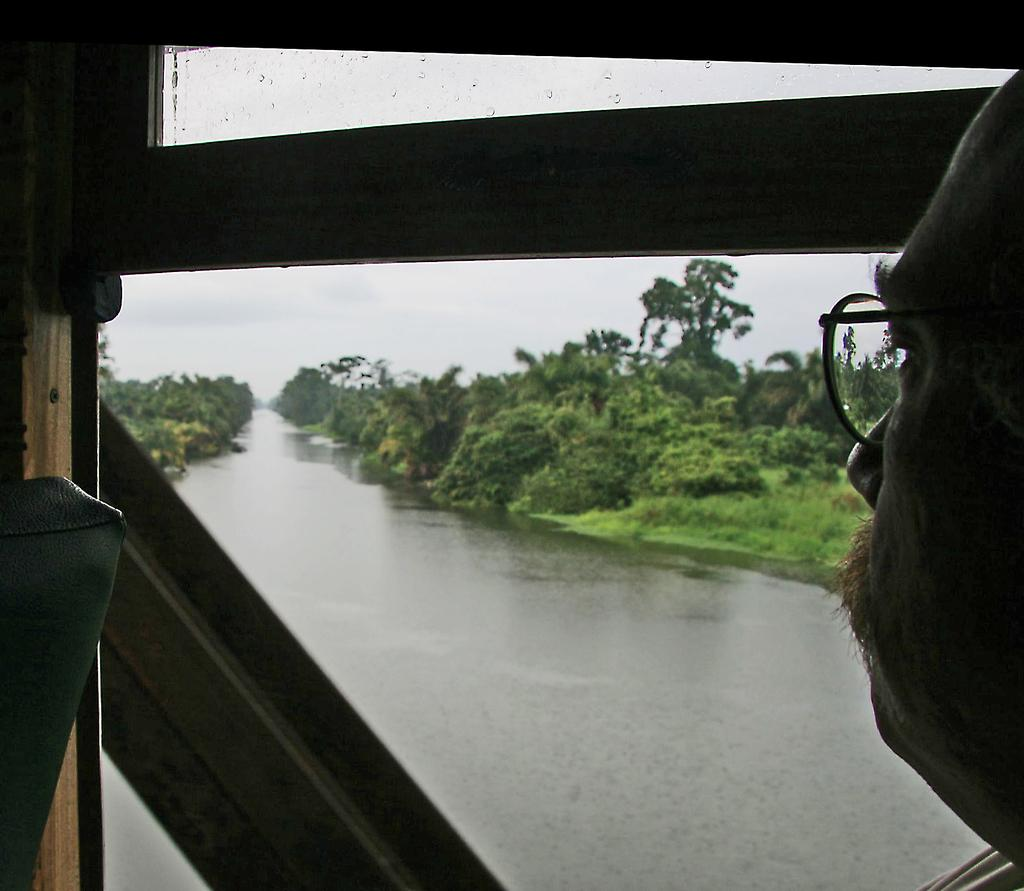Who or what is present in the image? There is a person in the image. What is a prominent feature in the background of the image? There is a window in the image. What can be seen through the window? Water, trees, and the sky are visible through the window. What type of sock is the person wearing in the image? There is no sock visible in the image, as the person's feet are not shown. What is the aftermath of the event depicted in the image? There is no event depicted in the image, so there is no aftermath to discuss. 